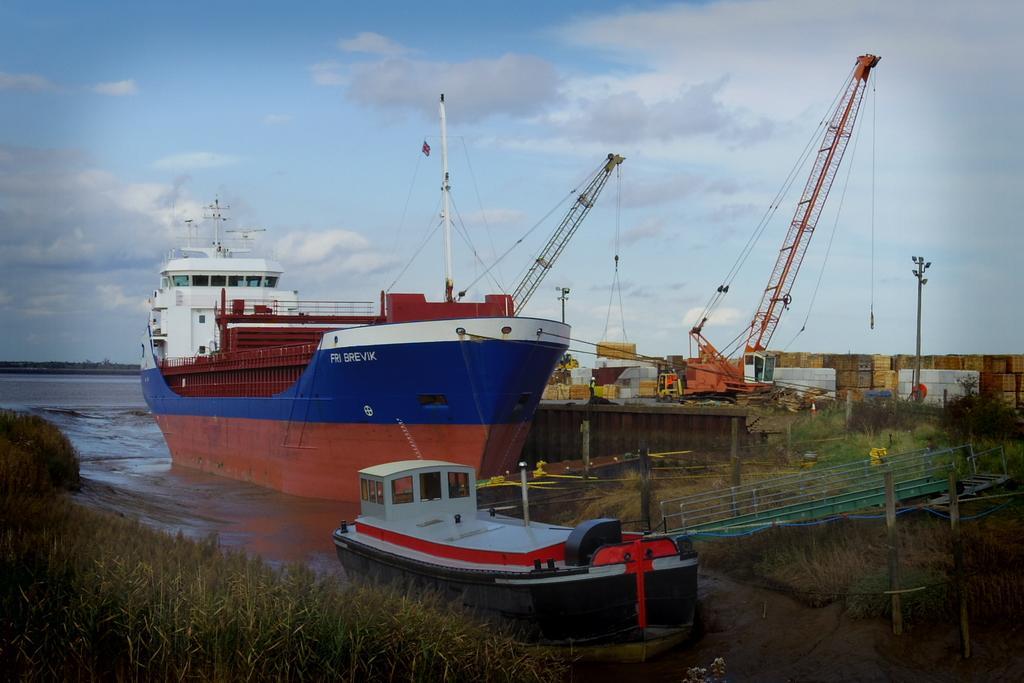In one or two sentences, can you explain what this image depicts? In this image in the front there's grass on the ground. In the center there is a boat and there is a walkway and there is a ship. In the background there are towers and there are poles and there are objects and the sky is cloudy and there is water in the background. 